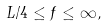<formula> <loc_0><loc_0><loc_500><loc_500>L / 4 \leq f \leq \infty ,</formula> 